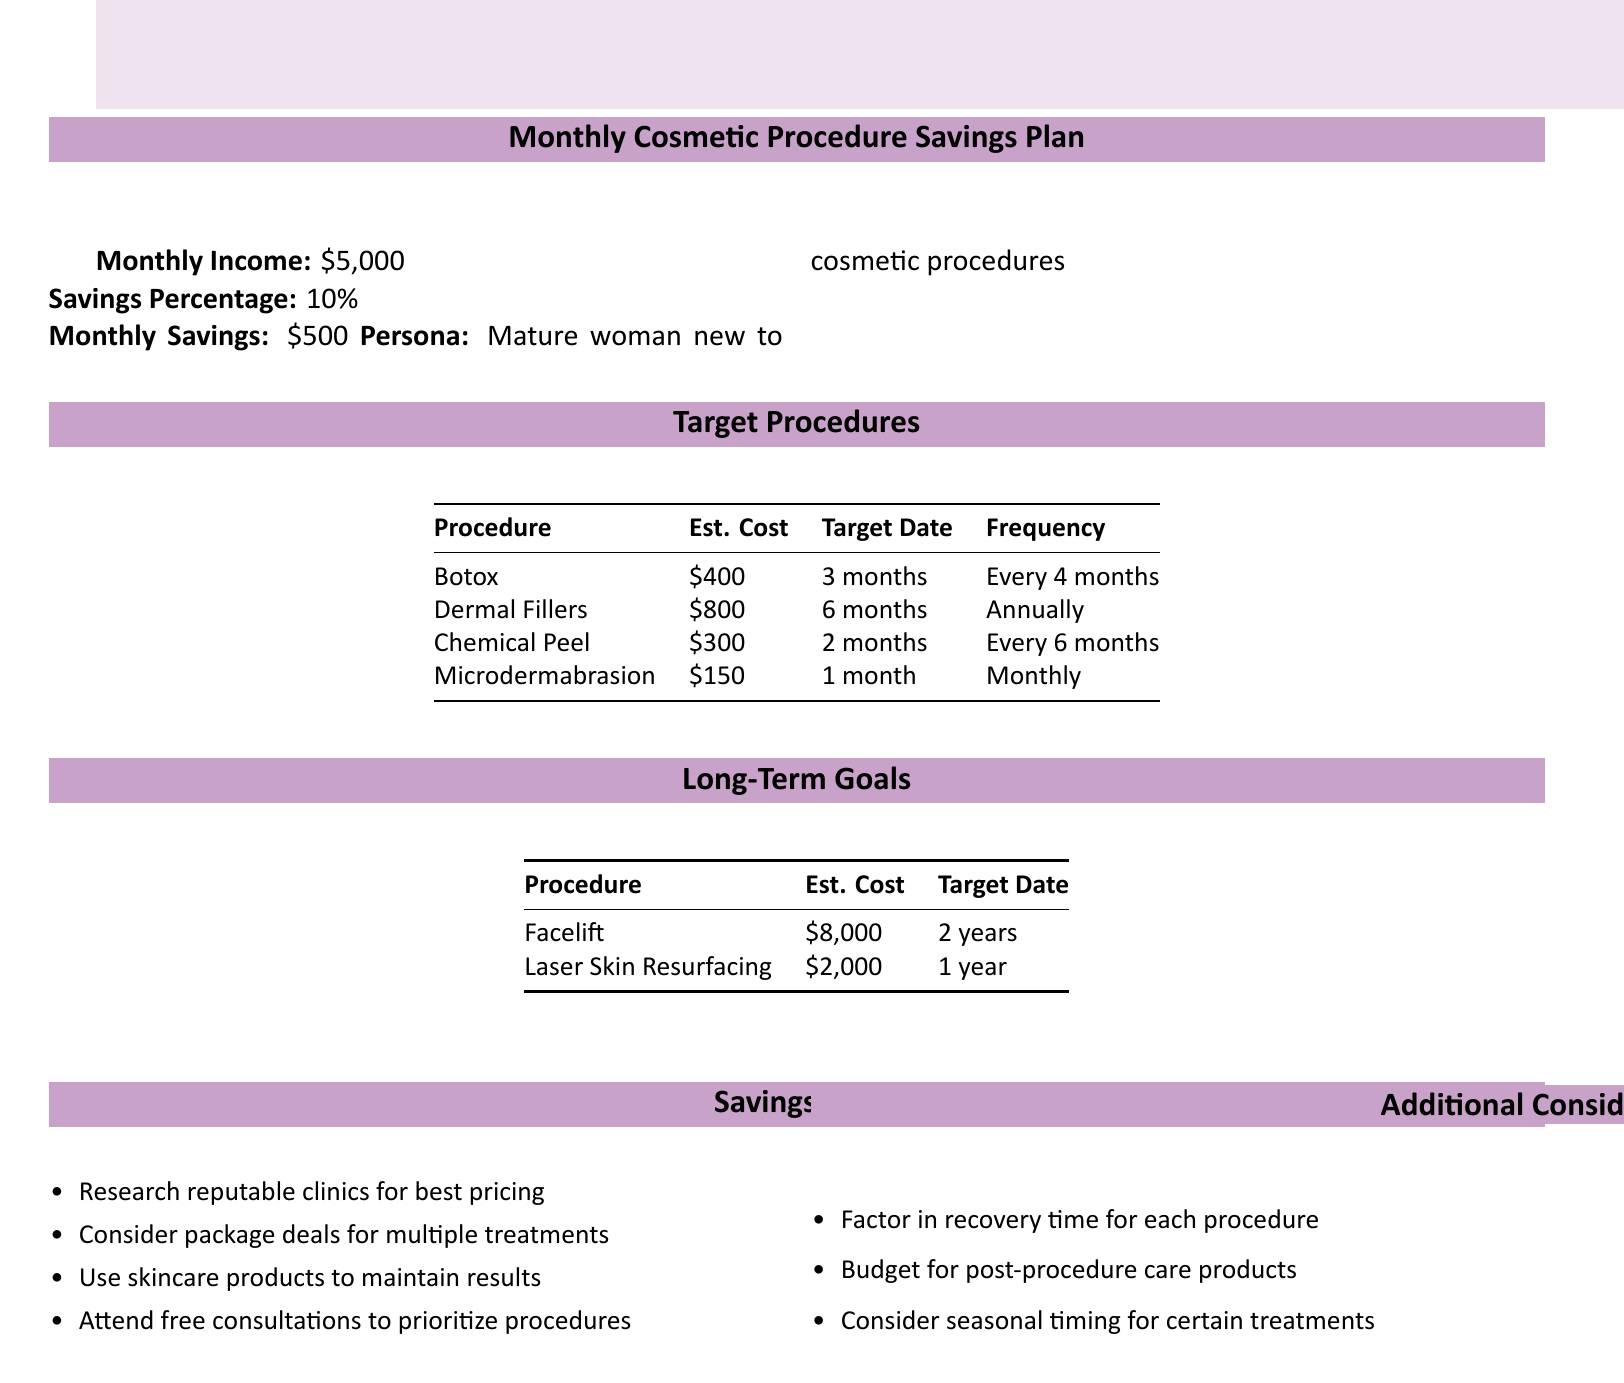what is the monthly savings amount? The monthly savings amount is calculated based on the income and savings percentage, which is $5,000 * 10%.
Answer: $500 how much is Botox estimated to cost? The estimated cost for Botox is provided in the target procedures section, which is $400.
Answer: $400 when is the target date for the Chemical Peel? The target date for the Chemical Peel is listed in the table, which is in 2 months.
Answer: 2 months what is the frequency of Microdermabrasion treatments? The frequency for Microdermabrasion is mentioned in the document, which states it should be done monthly.
Answer: Monthly how many procedures are listed under Long-Term Goals? The number of procedures listed under Long-Term Goals can be found by counting in that section, which is 2.
Answer: 2 what is the total estimated cost for a Facelift? The estimated cost for a Facelift is listed in the Long-Term Goals section, which is $8,000.
Answer: $8,000 what percentage of monthly income is allocated to savings? The document specifies the savings percentage based on the monthly income, which is 10%.
Answer: 10% what is a suggested savings tip related to procedures? The document lists several tips, one of which is to consider package deals for multiple treatments.
Answer: package deals how often should Dermal Fillers be received? The frequency for Dermal Fillers is outlined in the target procedures, stating it should be received annually.
Answer: Annually when is the target date for Laser Skin Resurfacing? The target date for Laser Skin Resurfacing is provided in the Long-Term Goals section, which is in 1 year.
Answer: 1 year 